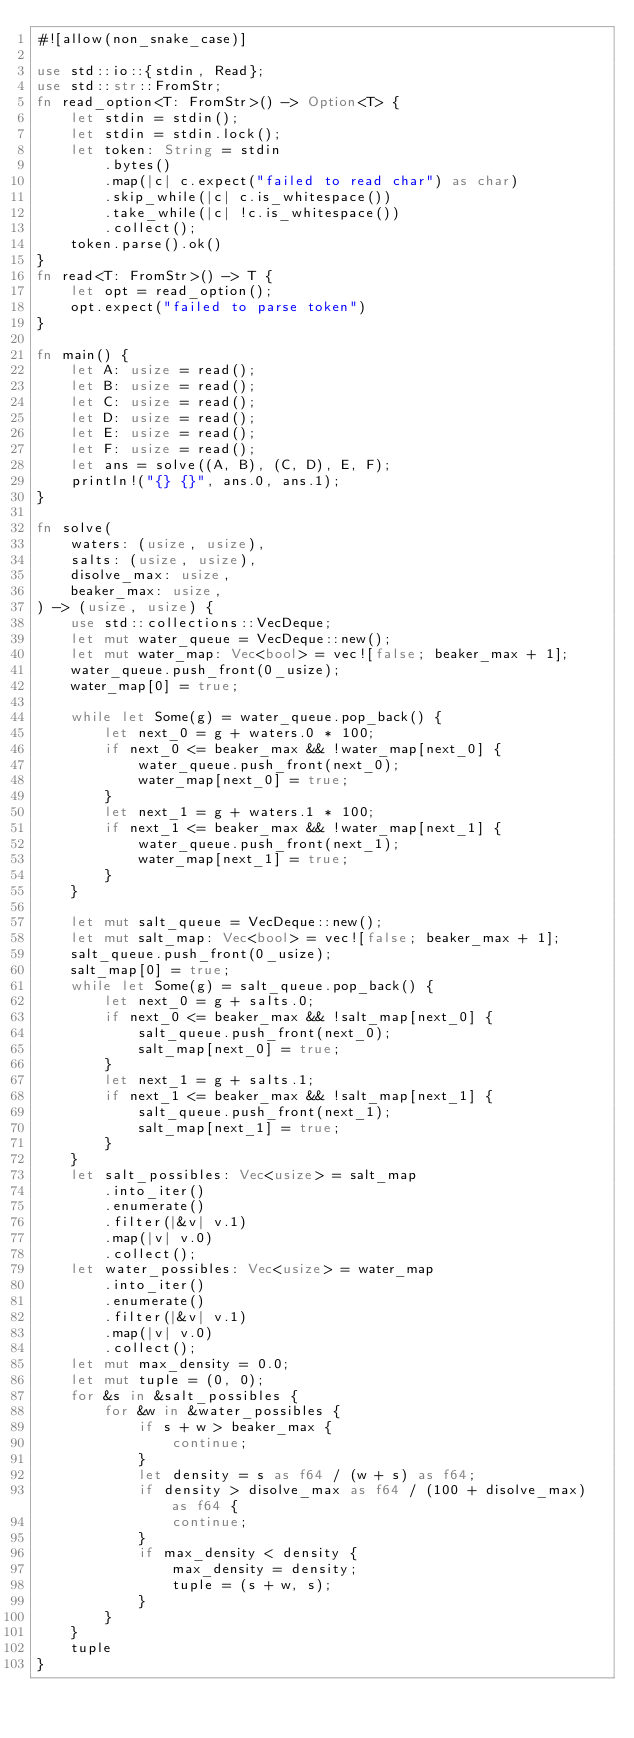Convert code to text. <code><loc_0><loc_0><loc_500><loc_500><_Rust_>#![allow(non_snake_case)]

use std::io::{stdin, Read};
use std::str::FromStr;
fn read_option<T: FromStr>() -> Option<T> {
    let stdin = stdin();
    let stdin = stdin.lock();
    let token: String = stdin
        .bytes()
        .map(|c| c.expect("failed to read char") as char)
        .skip_while(|c| c.is_whitespace())
        .take_while(|c| !c.is_whitespace())
        .collect();
    token.parse().ok()
}
fn read<T: FromStr>() -> T {
    let opt = read_option();
    opt.expect("failed to parse token")
}

fn main() {
    let A: usize = read();
    let B: usize = read();
    let C: usize = read();
    let D: usize = read();
    let E: usize = read();
    let F: usize = read();
    let ans = solve((A, B), (C, D), E, F);
    println!("{} {}", ans.0, ans.1);
}

fn solve(
    waters: (usize, usize),
    salts: (usize, usize),
    disolve_max: usize,
    beaker_max: usize,
) -> (usize, usize) {
    use std::collections::VecDeque;
    let mut water_queue = VecDeque::new();
    let mut water_map: Vec<bool> = vec![false; beaker_max + 1];
    water_queue.push_front(0_usize);
    water_map[0] = true;

    while let Some(g) = water_queue.pop_back() {
        let next_0 = g + waters.0 * 100;
        if next_0 <= beaker_max && !water_map[next_0] {
            water_queue.push_front(next_0);
            water_map[next_0] = true;
        }
        let next_1 = g + waters.1 * 100;
        if next_1 <= beaker_max && !water_map[next_1] {
            water_queue.push_front(next_1);
            water_map[next_1] = true;
        }
    }

    let mut salt_queue = VecDeque::new();
    let mut salt_map: Vec<bool> = vec![false; beaker_max + 1];
    salt_queue.push_front(0_usize);
    salt_map[0] = true;
    while let Some(g) = salt_queue.pop_back() {
        let next_0 = g + salts.0;
        if next_0 <= beaker_max && !salt_map[next_0] {
            salt_queue.push_front(next_0);
            salt_map[next_0] = true;
        }
        let next_1 = g + salts.1;
        if next_1 <= beaker_max && !salt_map[next_1] {
            salt_queue.push_front(next_1);
            salt_map[next_1] = true;
        }
    }
    let salt_possibles: Vec<usize> = salt_map
        .into_iter()
        .enumerate()
        .filter(|&v| v.1)
        .map(|v| v.0)
        .collect();
    let water_possibles: Vec<usize> = water_map
        .into_iter()
        .enumerate()
        .filter(|&v| v.1)
        .map(|v| v.0)
        .collect();
    let mut max_density = 0.0;
    let mut tuple = (0, 0);
    for &s in &salt_possibles {
        for &w in &water_possibles {
            if s + w > beaker_max {
                continue;
            }
            let density = s as f64 / (w + s) as f64;
            if density > disolve_max as f64 / (100 + disolve_max) as f64 {
                continue;
            }
            if max_density < density {
                max_density = density;
                tuple = (s + w, s);
            }
        }
    }
    tuple
}
</code> 